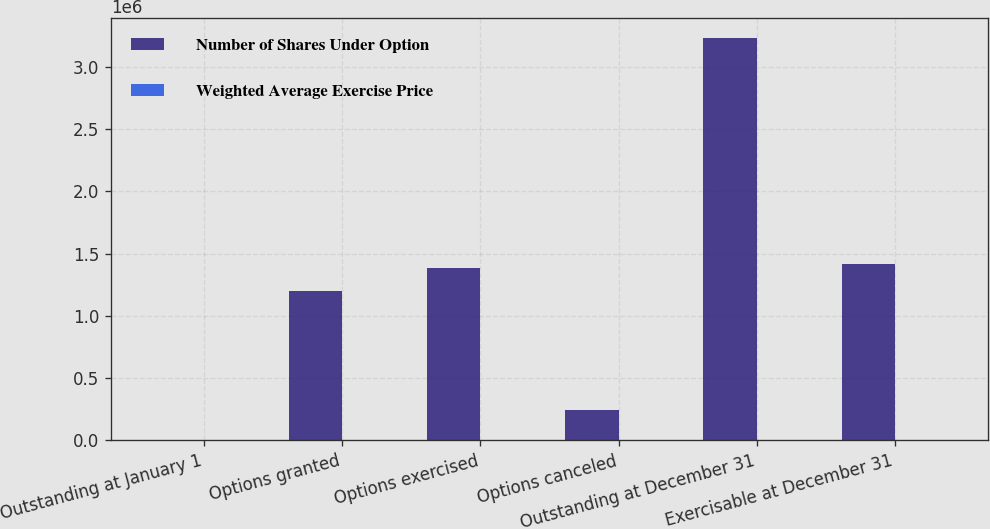Convert chart. <chart><loc_0><loc_0><loc_500><loc_500><stacked_bar_chart><ecel><fcel>Outstanding at January 1<fcel>Options granted<fcel>Options exercised<fcel>Options canceled<fcel>Outstanding at December 31<fcel>Exercisable at December 31<nl><fcel>Number of Shares Under Option<fcel>53.44<fcel>1.20096e+06<fcel>1.38602e+06<fcel>245056<fcel>3.23168e+06<fcel>1.41373e+06<nl><fcel>Weighted Average Exercise Price<fcel>16.2<fcel>53.44<fcel>15.92<fcel>32.47<fcel>28.93<fcel>19.27<nl></chart> 